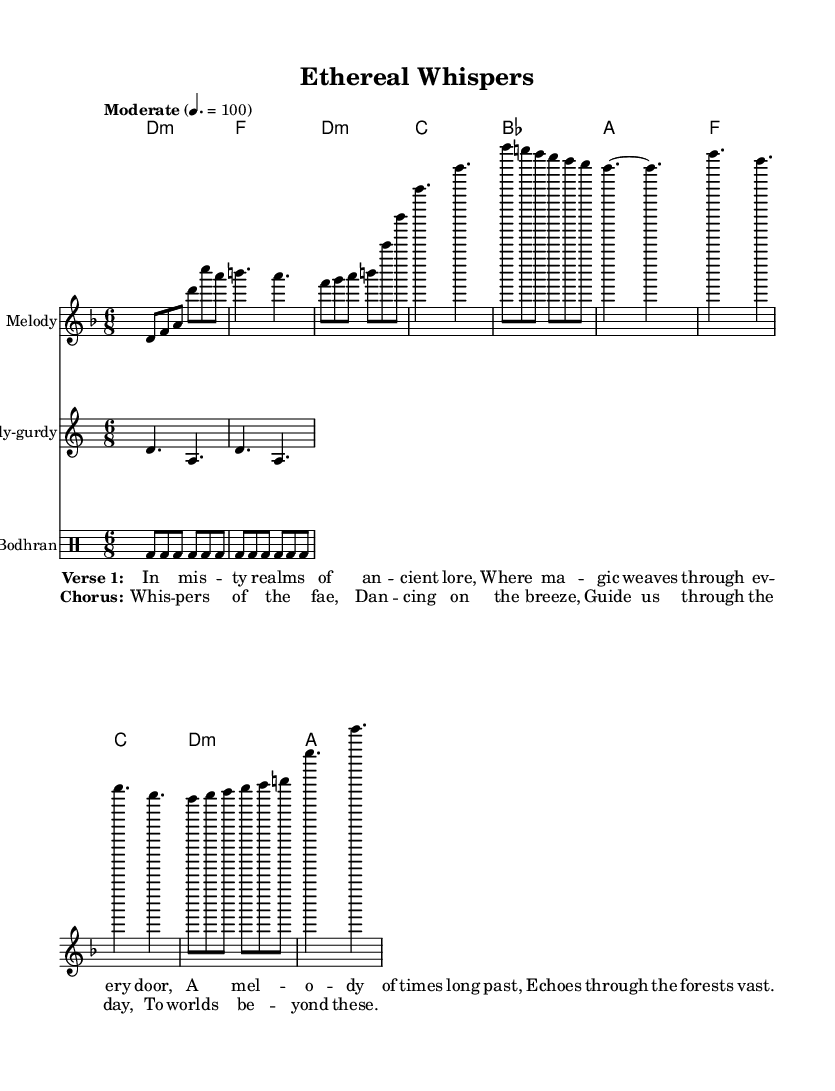What is the key signature of this music? The key signature indicated in the score is D minor, which is represented by one flat (B flat). The presence of the key signature at the beginning of the staff helps determine the scale used in the piece.
Answer: D minor What is the time signature of the piece? The time signature shown at the beginning of the score is 6/8, which indicates that there are six eighth notes in each measure, creating a feeling of a compound meter.
Answer: 6/8 What is the tempo marking for this music? The tempo marking indicates "Moderate" at a speed of 4 beats per minute equating to 100, implying a steady, moderate pace suitable for the introspective nature of the music.
Answer: Moderate How many bars are in the chorus section? The chorus consists of four lines, each typically representing one bar of music, confirming that there are four distinct measures.
Answer: 4 Which instruments are included in this score? The score features a melody (presumably for voice or lead instrument), a hurdy-gurdy, and a bodhran, as indicated by the instrumentation labels at the start of each staff.
Answer: Melody, Hurdy-gurdy, Bodhran What type of folk instrument is featured prominently in this composition? The hurdy-gurdy is highlighted within the score, noted for its unique sound often used in traditional and folk music, making it a central feature in this experimental piece.
Answer: Hurdy-gurdy What lyrical theme is represented in the chorus? The lyrics of the chorus evoke imagery and themes related to nature and fantasy, specifically referring to the "whispers of the fae," aligning with the overall ethereal tone of the music.
Answer: Whispers of the fae 